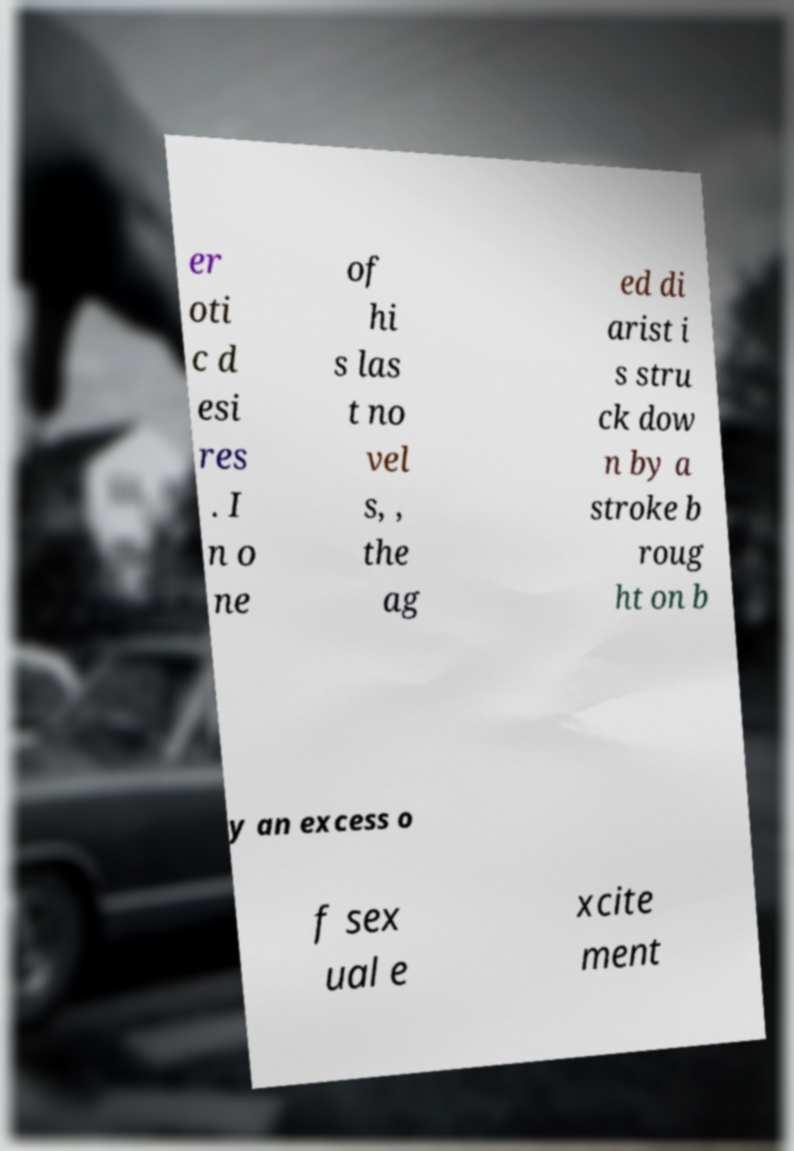Could you assist in decoding the text presented in this image and type it out clearly? er oti c d esi res . I n o ne of hi s las t no vel s, , the ag ed di arist i s stru ck dow n by a stroke b roug ht on b y an excess o f sex ual e xcite ment 